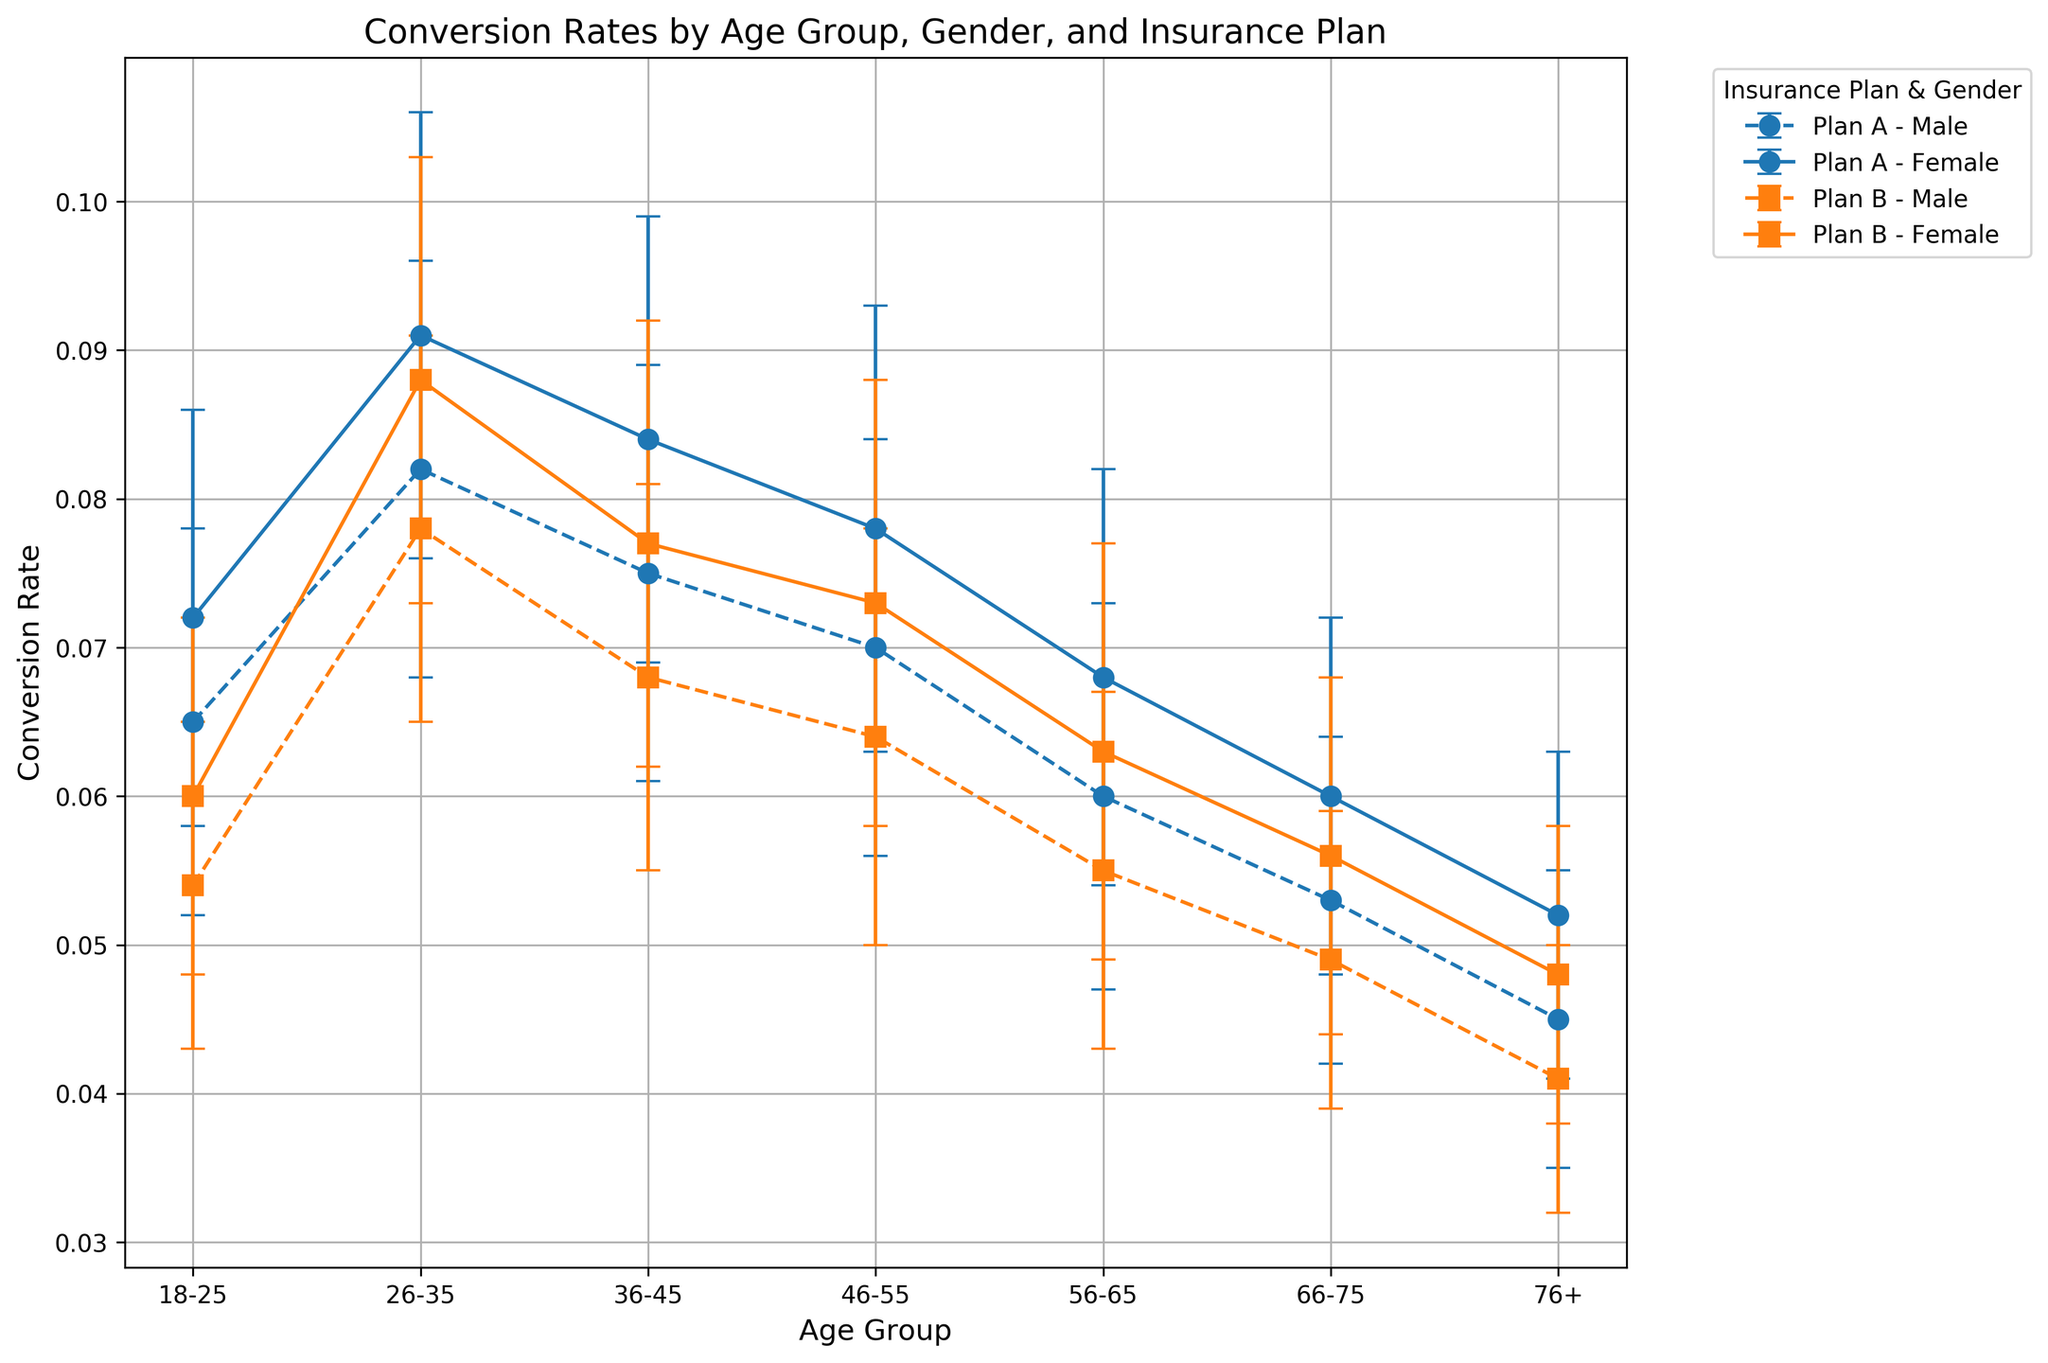Which age group has the highest conversion rate for Plan A among males? First, identify the conversion rates for males under Plan A across different age groups. The values are 0.065 (18-25), 0.082 (26-35), 0.075 (36-45), 0.070 (46-55), 0.060 (56-65), 0.053 (66-75), and 0.045 (76+). The highest rate is 0.082 for the 26-35 age group.
Answer: 26-35 Which gender has a higher conversion rate for Plan B in the 36-45 age group? Compare the conversion rates for males and females under Plan B in the 36-45 age group. The conversion rates are 0.068 for males and 0.077 for females. Since 0.077 is higher than 0.068, females have a higher conversion rate.
Answer: Female What is the difference in conversion rates between Plan A and Plan B for the 46-55 female group? Identify the conversion rates for females in the 46-55 age group for Plan A and Plan B. The values are 0.078 and 0.073, respectively. Subtract the conversion rate of Plan B from Plan A, which is 0.078 - 0.073 = 0.005.
Answer: 0.005 Among the 18-25 age group, which gender and insurance plan combination has the lowest conversion rate? Compare the conversion rates within the 18-25 age group for both genders and plans. The rates are 0.065 (Male, Plan A), 0.072 (Female, Plan A), 0.054 (Male, Plan B), 0.060 (Female, Plan B). The lowest rate is 0.054 for males under Plan B.
Answer: Male, Plan B What is the average conversion rate for females across all age groups for Plan A? Add up the conversion rates for females under Plan A across all age groups and divide by the number of age groups. The rates are 0.072, 0.091, 0.084, 0.078, 0.068, 0.060, and 0.052. Summing these gives 0.505, and there are 7 age groups, so 0.505 / 7 = 0.0721.
Answer: 0.0721 